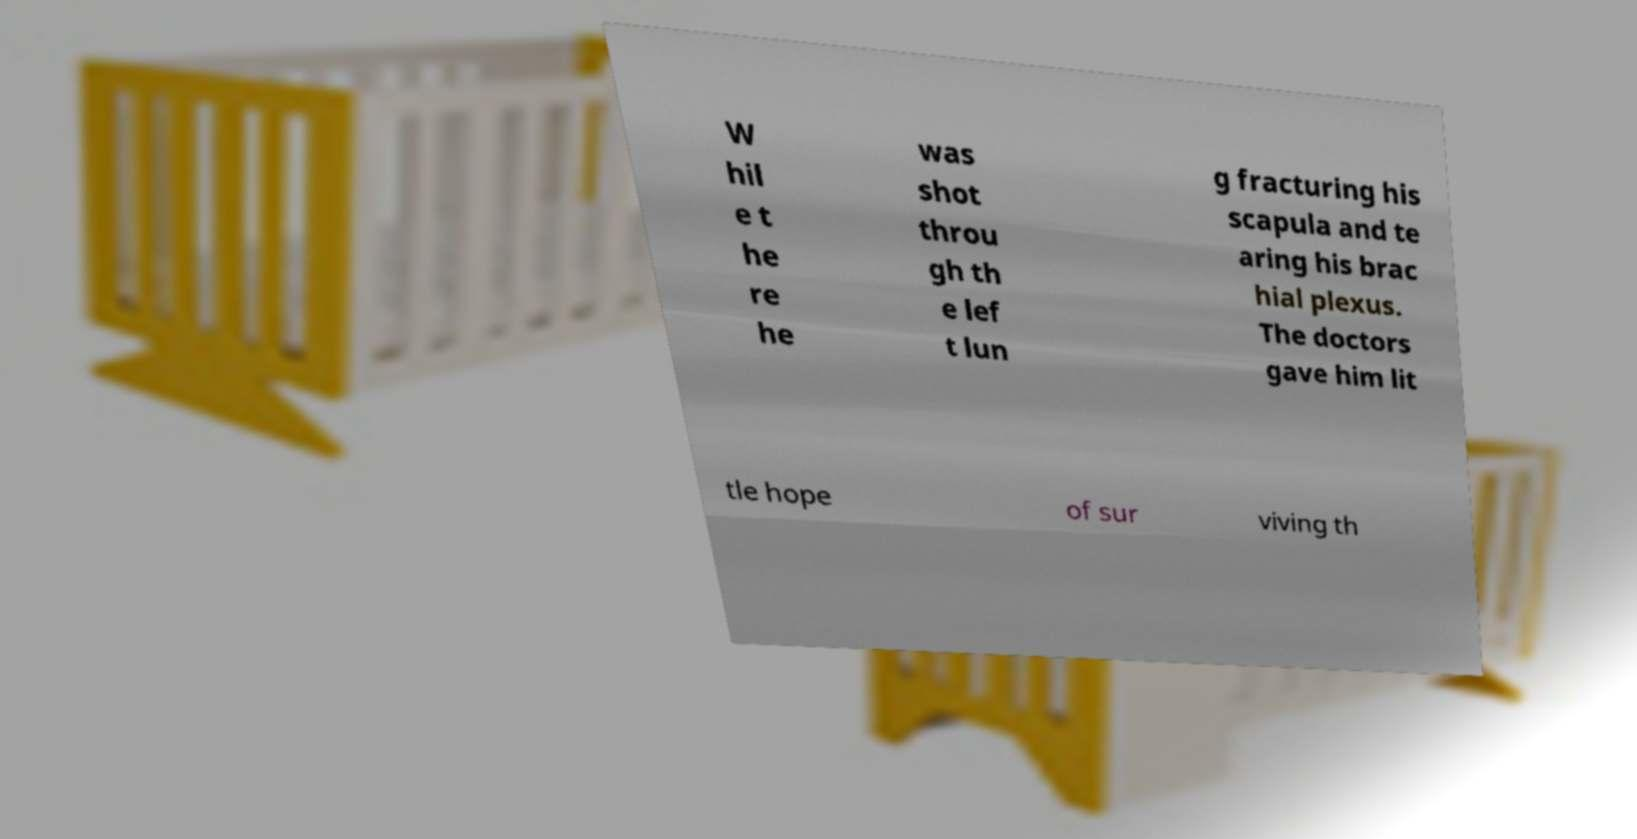Can you read and provide the text displayed in the image?This photo seems to have some interesting text. Can you extract and type it out for me? W hil e t he re he was shot throu gh th e lef t lun g fracturing his scapula and te aring his brac hial plexus. The doctors gave him lit tle hope of sur viving th 